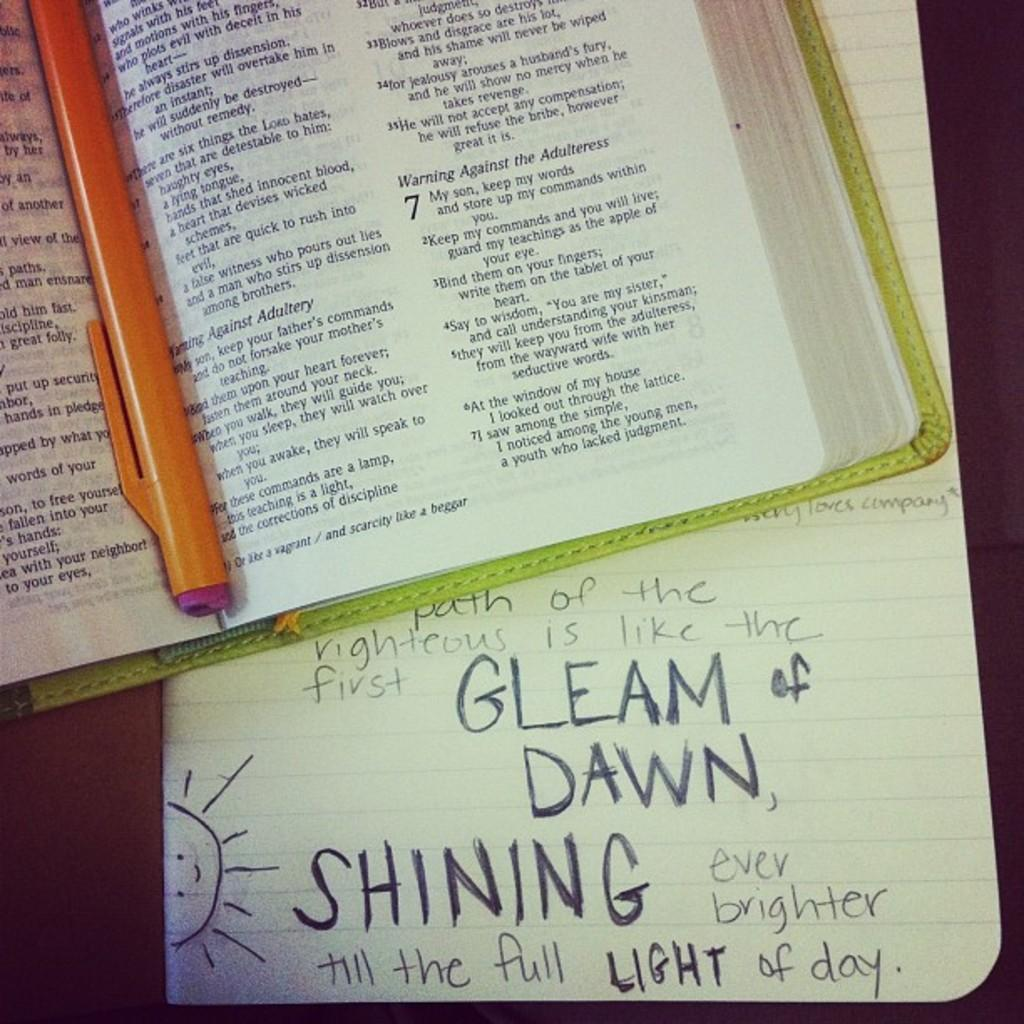<image>
Provide a brief description of the given image. Someone has scribbled Gleam of Dawn and Shining Light on a piece of paper. 